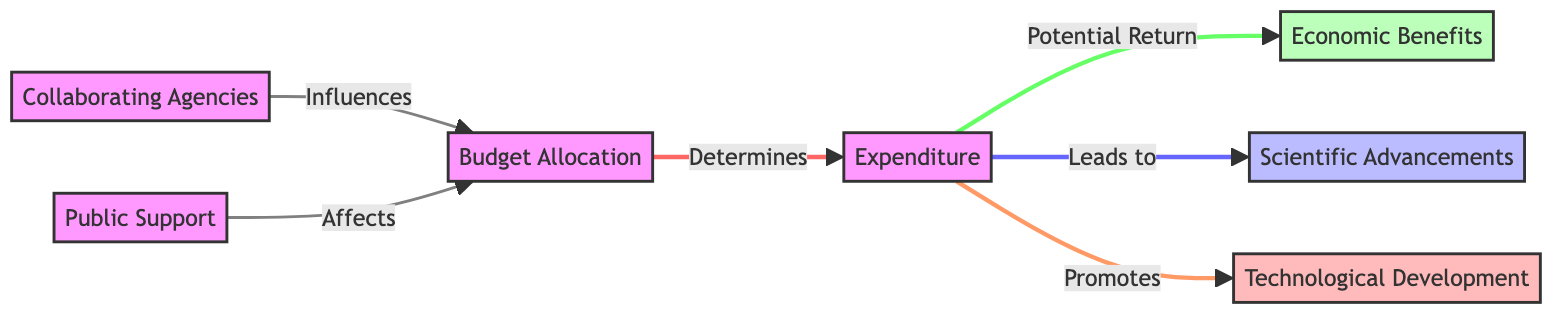What is the main influence on budget allocation? The diagram indicates that collaborating agencies directly influence budget allocation, as shown by the connecting arrow from CA to BA.
Answer: Collaborating Agencies How many types of outcomes result from expenditures? The diagram shows three distinct outcomes resulting from expenditures: Economic Benefits, Scientific Advancements, and Technological Development, indicating multiple results.
Answer: Three What is the relationship between expenditures and public support? The diagram does not show a direct relationship between expenditures and public support; however, public support influences budget allocation, which indirectly affects expenditures.
Answer: Indirect What comes after expenditures in terms of outcomes? According to the diagram, expenditures lead to three outcomes: Economic Benefits, Scientific Advancements, and Technological Development, indicating these are subsequent results.
Answer: Economic Benefits, Scientific Advancements, Technological Development Which outcome is classified as scientific? The label of the node named Scientific Advancements is classified as scientific in the diagram, thereby identifying the specific outcome associated with science.
Answer: Scientific Advancements Which variable affects budget allocation the most? The diagram suggests both collaborating agencies and public support influence budget allocation; however, it does not clearly differentiate which has a greater impact, making it a matter of interpretation.
Answer: Both Collaborating Agencies and Public Support What does the budget allocation determine? The flowchart shows that budget allocation directly determines expenditures, which establishes the link between these two nodes.
Answer: Expenditures Which node has a direct link to technological development? Expenditures promote technological development directly according to the diagram, as represented by the arrow pointing from EX to TD.
Answer: Expenditures 